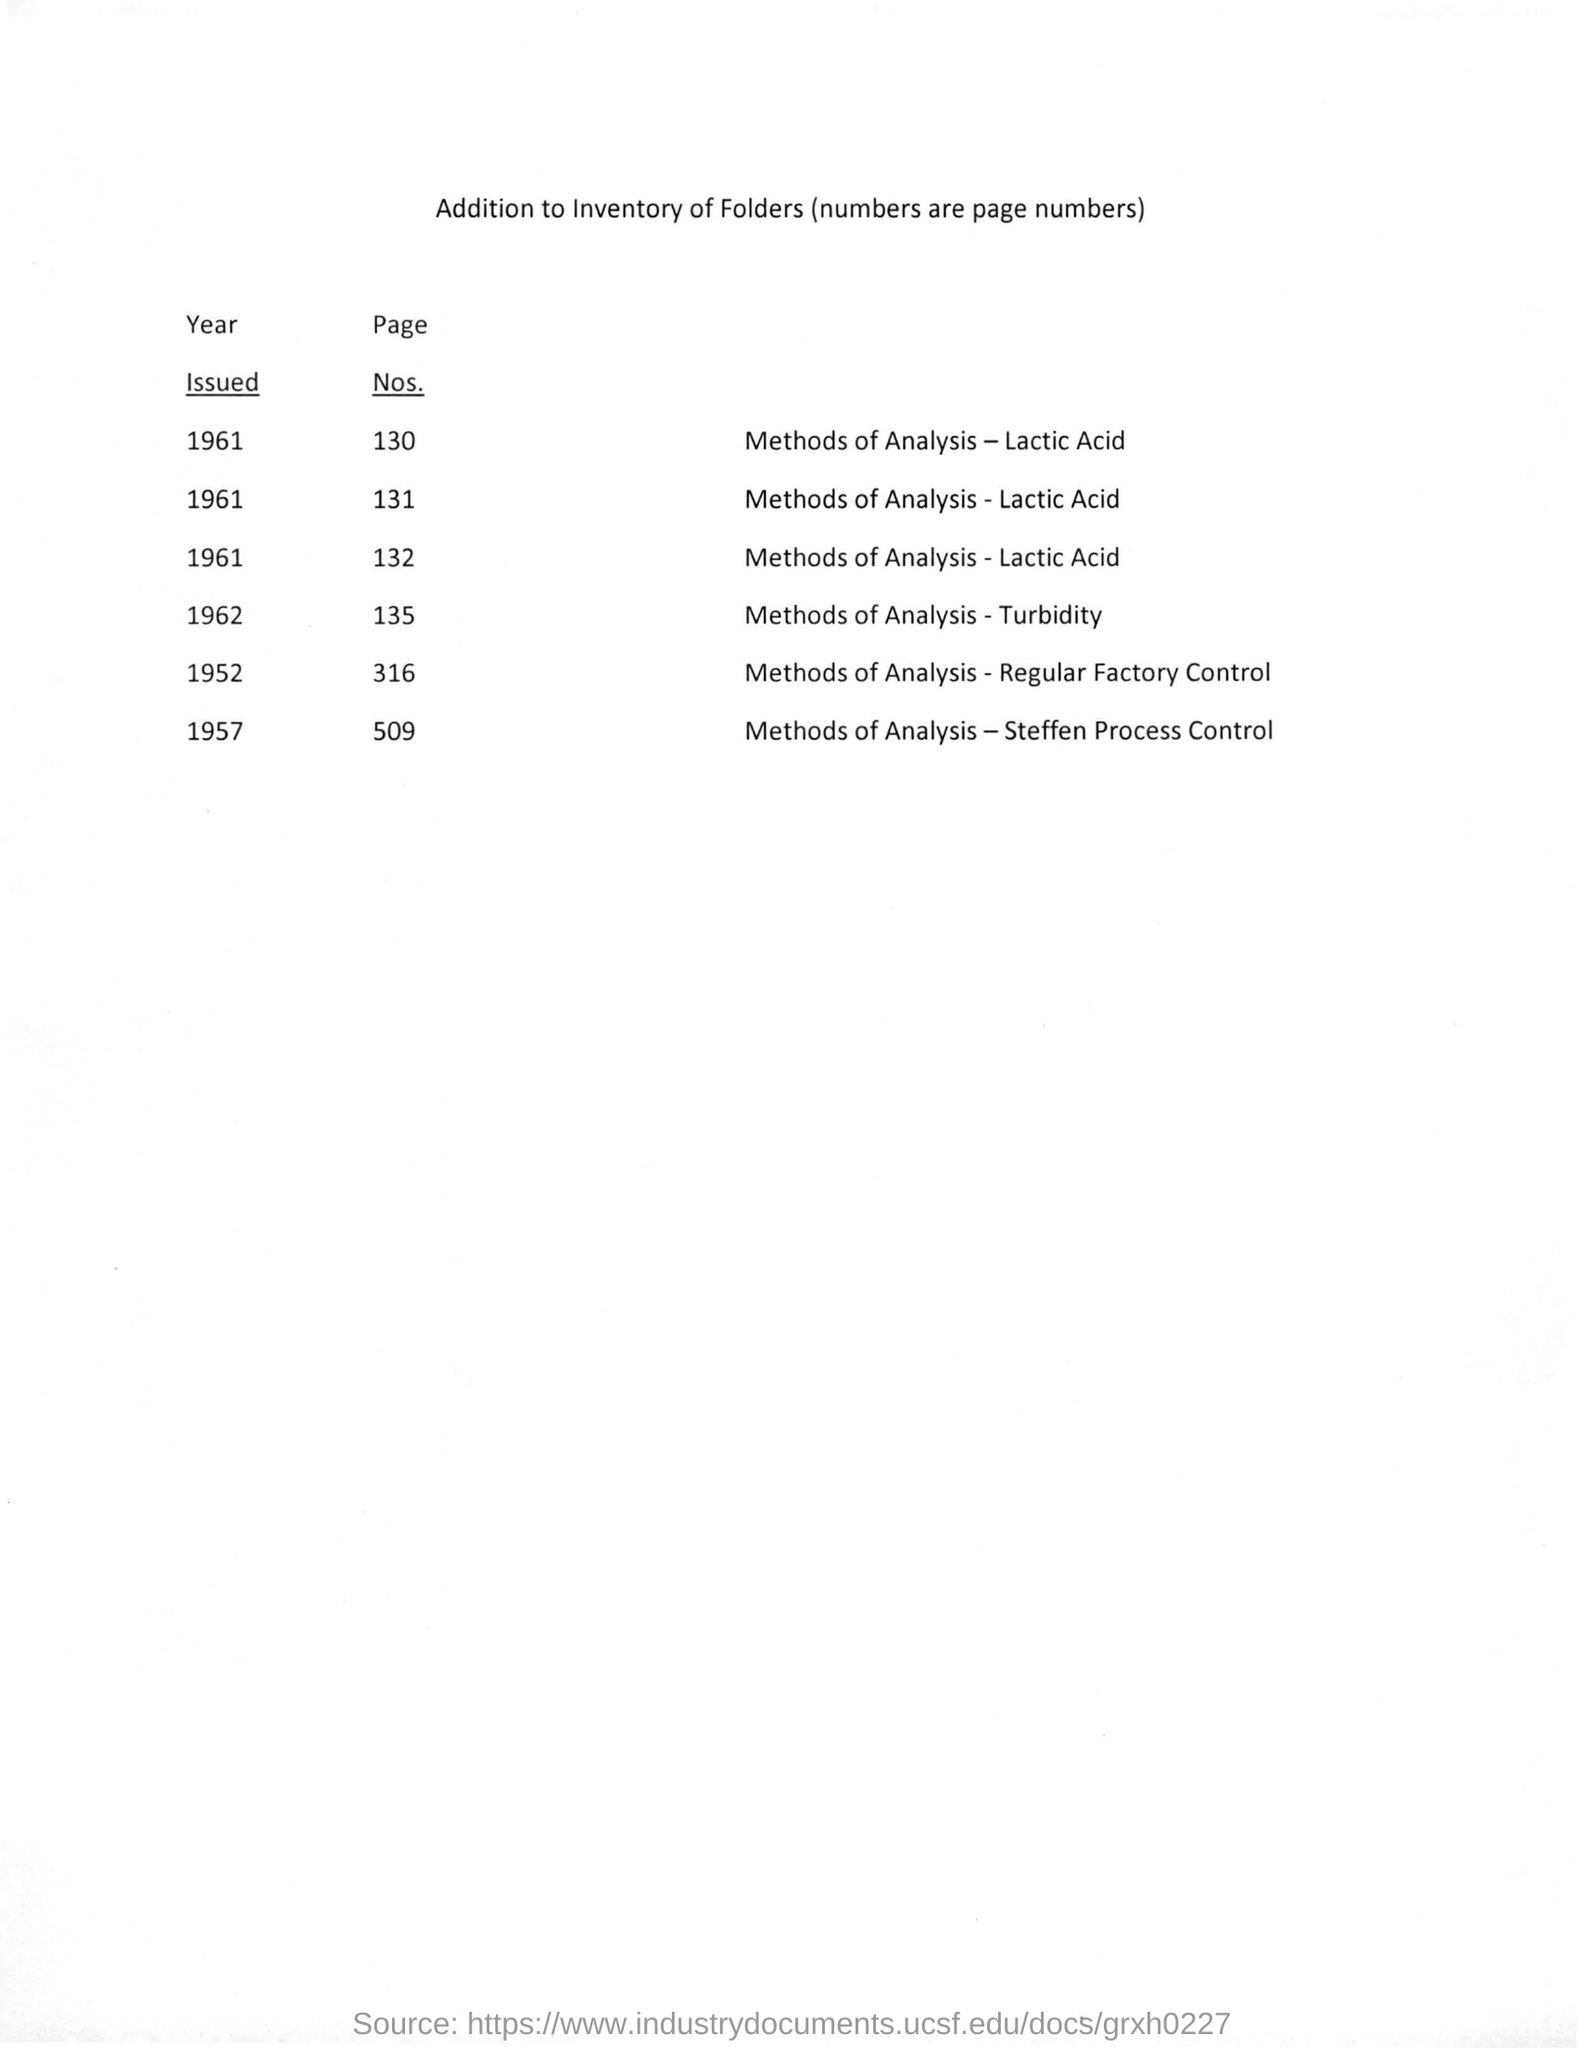How many number of pages are there for method of analysis - steffen process control ?
Keep it short and to the point. 509. How many no. of pages are mentioned for method of analysis - regular factory control ?
Offer a terse response. 316. What is the issued year for method of analysis- turbidity ?
Offer a very short reply. 1962. 